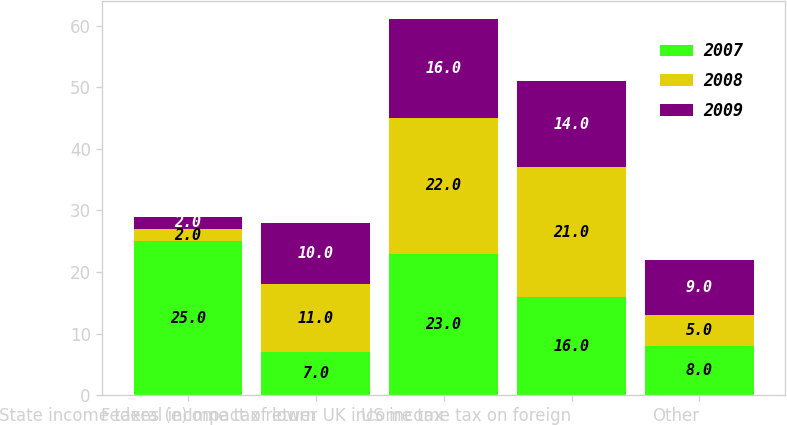Convert chart. <chart><loc_0><loc_0><loc_500><loc_500><stacked_bar_chart><ecel><fcel>State income taxes (e)<fcel>Federal income tax return<fcel>Impact of lower UK income tax<fcel>US income tax on foreign<fcel>Other<nl><fcel>2007<fcel>25<fcel>7<fcel>23<fcel>16<fcel>8<nl><fcel>2008<fcel>2<fcel>11<fcel>22<fcel>21<fcel>5<nl><fcel>2009<fcel>2<fcel>10<fcel>16<fcel>14<fcel>9<nl></chart> 